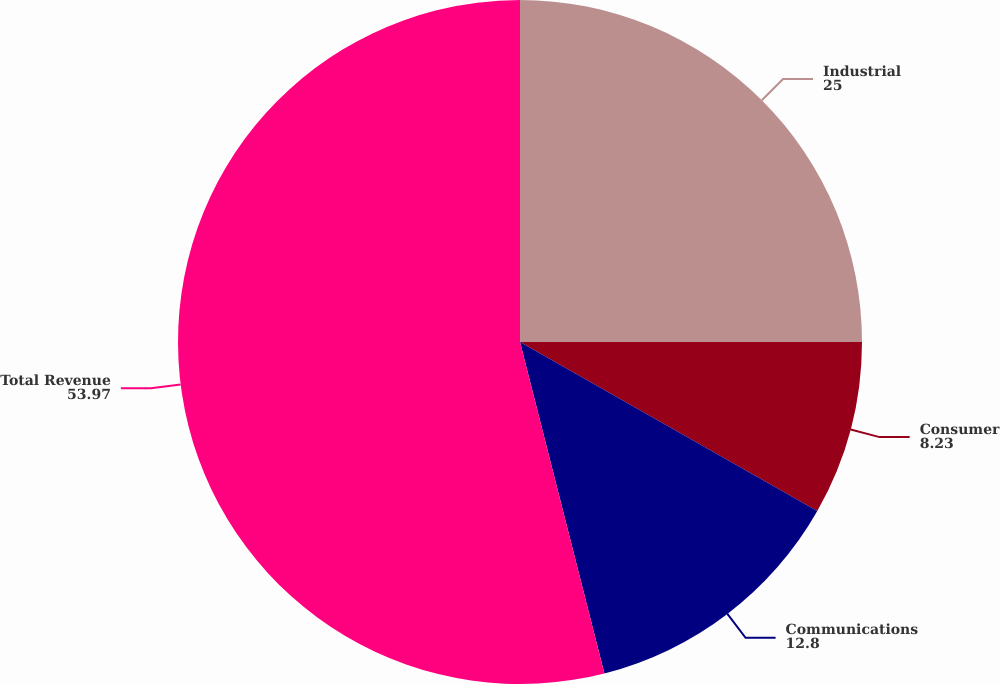Convert chart. <chart><loc_0><loc_0><loc_500><loc_500><pie_chart><fcel>Industrial<fcel>Consumer<fcel>Communications<fcel>Total Revenue<nl><fcel>25.0%<fcel>8.23%<fcel>12.8%<fcel>53.97%<nl></chart> 